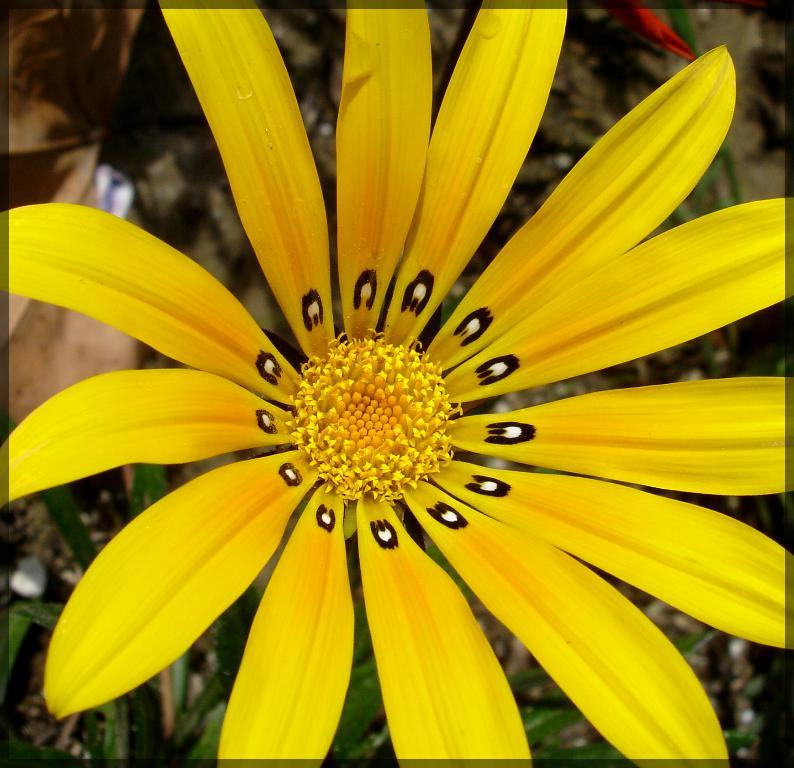What type of flower is present in the image? There is a yellow color flower in the image. What type of map can be seen in the image? There is no map present in the image; it features a yellow color flower. What type of jam is being made from the tree in the image? There is no tree or jam-making process depicted in the image; it only shows a yellow color flower. 